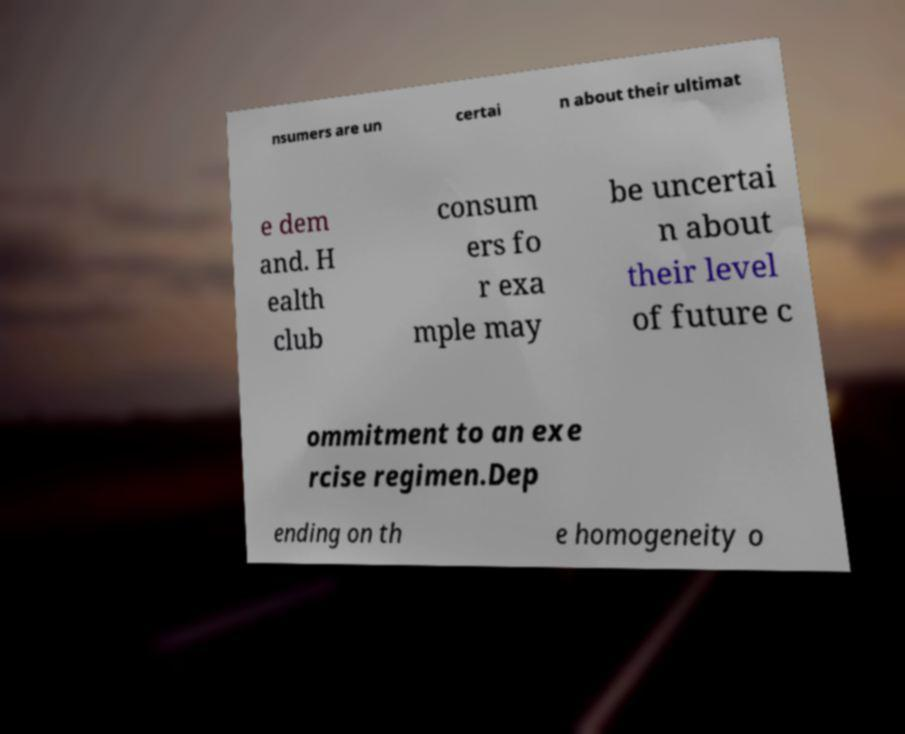Could you assist in decoding the text presented in this image and type it out clearly? nsumers are un certai n about their ultimat e dem and. H ealth club consum ers fo r exa mple may be uncertai n about their level of future c ommitment to an exe rcise regimen.Dep ending on th e homogeneity o 